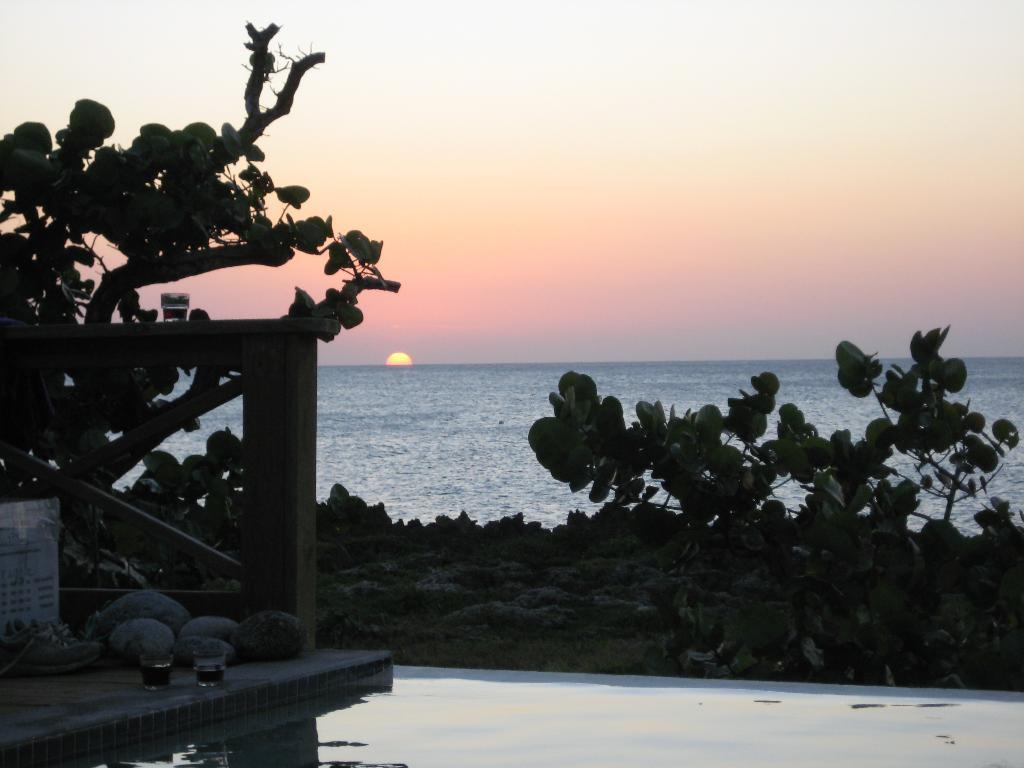What type of objects can be seen in the image? There are glasses, stones, and footwear in the image. What is present on the path in the image? There is a board on the path in the image. What type of natural elements can be seen in the image? There are leaves, branches, and water visible in the image. What can be seen in the background of the image? The sky is visible in the background of the image. What type of grass is growing on the wrist of the person in the image? There is no person present in the image, and therefore no wrist or grass growing on it. 